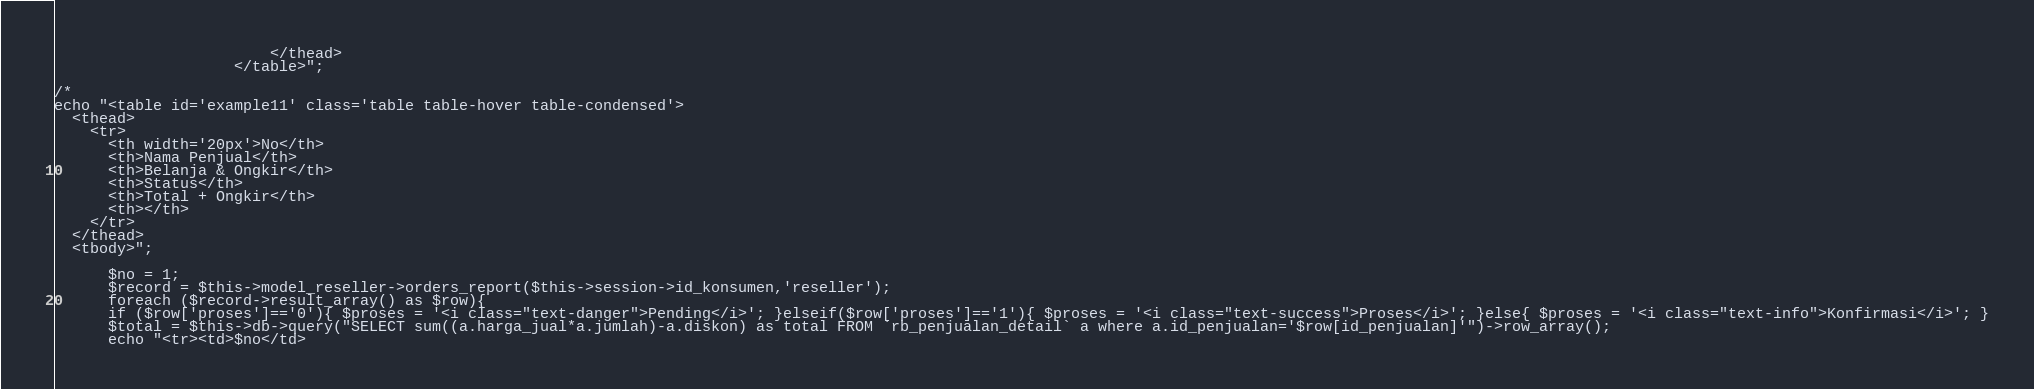<code> <loc_0><loc_0><loc_500><loc_500><_PHP_>                        </thead>
                    </table>";

/*
echo "<table id='example11' class='table table-hover table-condensed'>
  <thead>
    <tr>
      <th width='20px'>No</th>
      <th>Nama Penjual</th>
      <th>Belanja & Ongkir</th>
      <th>Status</th>
      <th>Total + Ongkir</th>
      <th></th>
    </tr>
  </thead>
  <tbody>";

      $no = 1;
      $record = $this->model_reseller->orders_report($this->session->id_konsumen,'reseller');
      foreach ($record->result_array() as $row){
      if ($row['proses']=='0'){ $proses = '<i class="text-danger">Pending</i>'; }elseif($row['proses']=='1'){ $proses = '<i class="text-success">Proses</i>'; }else{ $proses = '<i class="text-info">Konfirmasi</i>'; }
      $total = $this->db->query("SELECT sum((a.harga_jual*a.jumlah)-a.diskon) as total FROM `rb_penjualan_detail` a where a.id_penjualan='$row[id_penjualan]'")->row_array();
      echo "<tr><td>$no</td></code> 